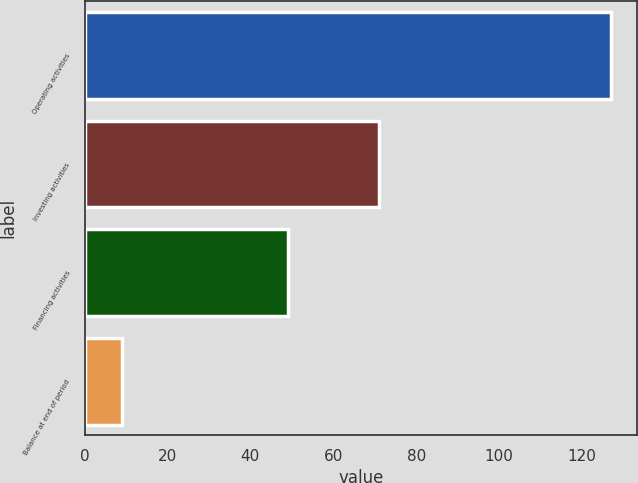<chart> <loc_0><loc_0><loc_500><loc_500><bar_chart><fcel>Operating activities<fcel>Investing activities<fcel>Financing activities<fcel>Balance at end of period<nl><fcel>127<fcel>71<fcel>49<fcel>9<nl></chart> 